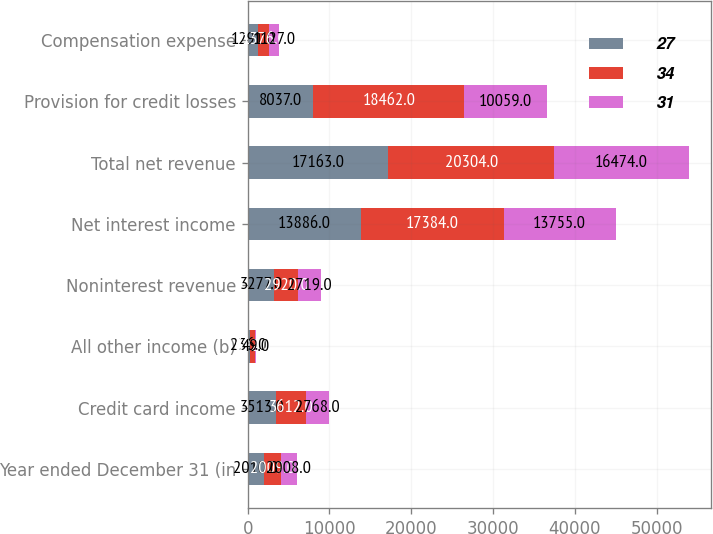Convert chart to OTSL. <chart><loc_0><loc_0><loc_500><loc_500><stacked_bar_chart><ecel><fcel>Year ended December 31 (in<fcel>Credit card income<fcel>All other income (b)<fcel>Noninterest revenue<fcel>Net interest income<fcel>Total net revenue<fcel>Provision for credit losses<fcel>Compensation expense<nl><fcel>27<fcel>2010<fcel>3513<fcel>236<fcel>3277<fcel>13886<fcel>17163<fcel>8037<fcel>1291<nl><fcel>34<fcel>2009<fcel>3612<fcel>692<fcel>2920<fcel>17384<fcel>20304<fcel>18462<fcel>1376<nl><fcel>31<fcel>2008<fcel>2768<fcel>49<fcel>2719<fcel>13755<fcel>16474<fcel>10059<fcel>1127<nl></chart> 